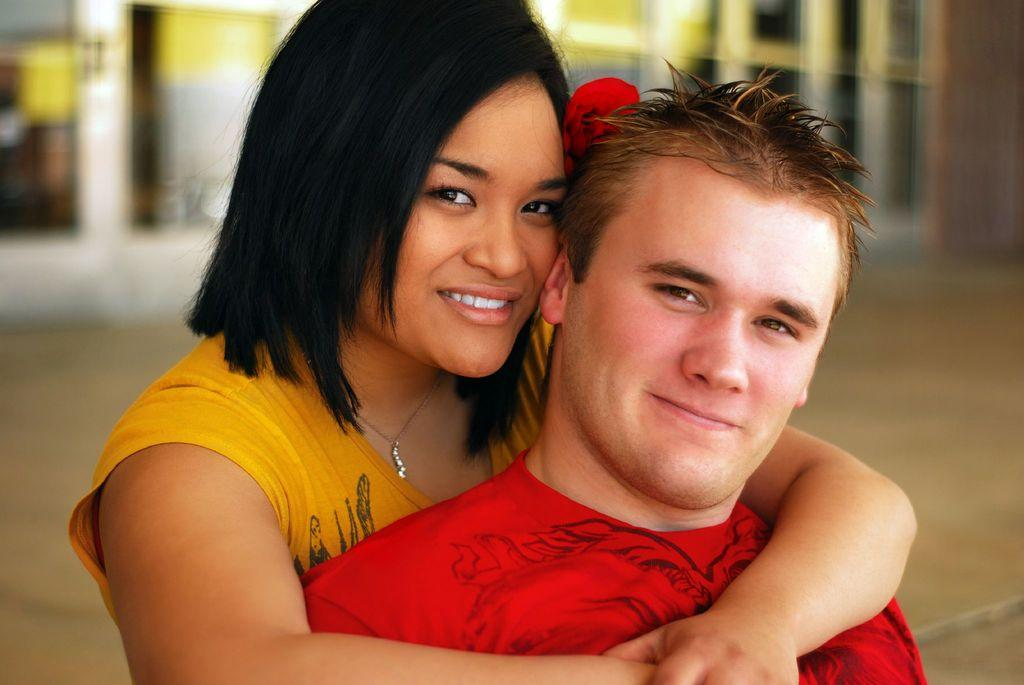How many people are present in the image? There are two people, a man and a woman, present in the image. What expressions do the man and woman have in the image? Both the man and woman are smiling in the image. What can be seen in the background of the image? There is ground and at least one building visible in the background of the image. How would you describe the quality of the background in the image? The background appears blurry in the image. What type of jar is the man holding in the image? There is no jar present in the image; the man is not holding anything. What time of day is it in the image, given the presence of a banana? There is no banana present in the image, so it cannot be used to determine the time of day. 